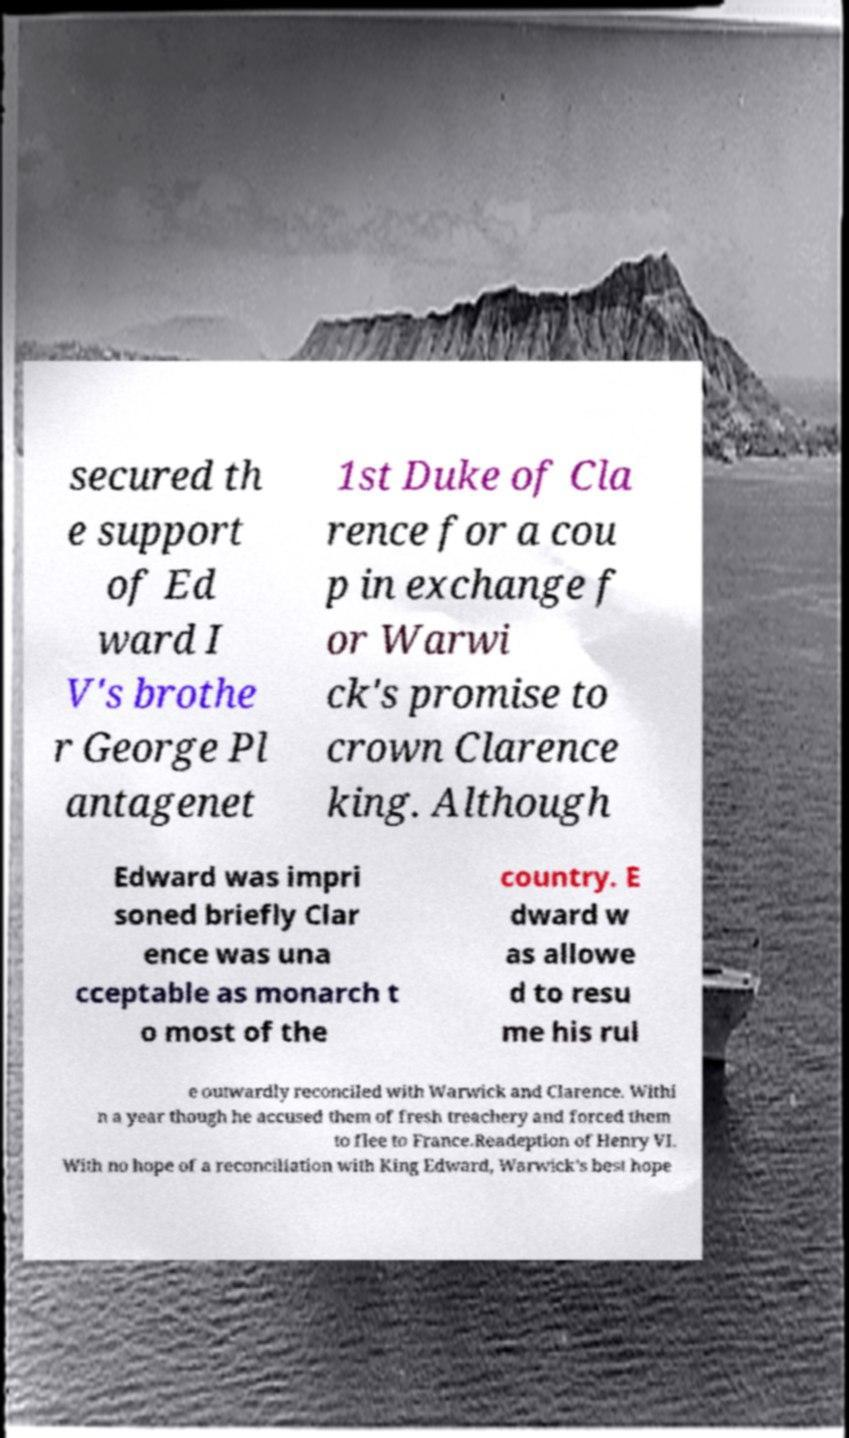Could you assist in decoding the text presented in this image and type it out clearly? secured th e support of Ed ward I V's brothe r George Pl antagenet 1st Duke of Cla rence for a cou p in exchange f or Warwi ck's promise to crown Clarence king. Although Edward was impri soned briefly Clar ence was una cceptable as monarch t o most of the country. E dward w as allowe d to resu me his rul e outwardly reconciled with Warwick and Clarence. Withi n a year though he accused them of fresh treachery and forced them to flee to France.Readeption of Henry VI. With no hope of a reconciliation with King Edward, Warwick's best hope 